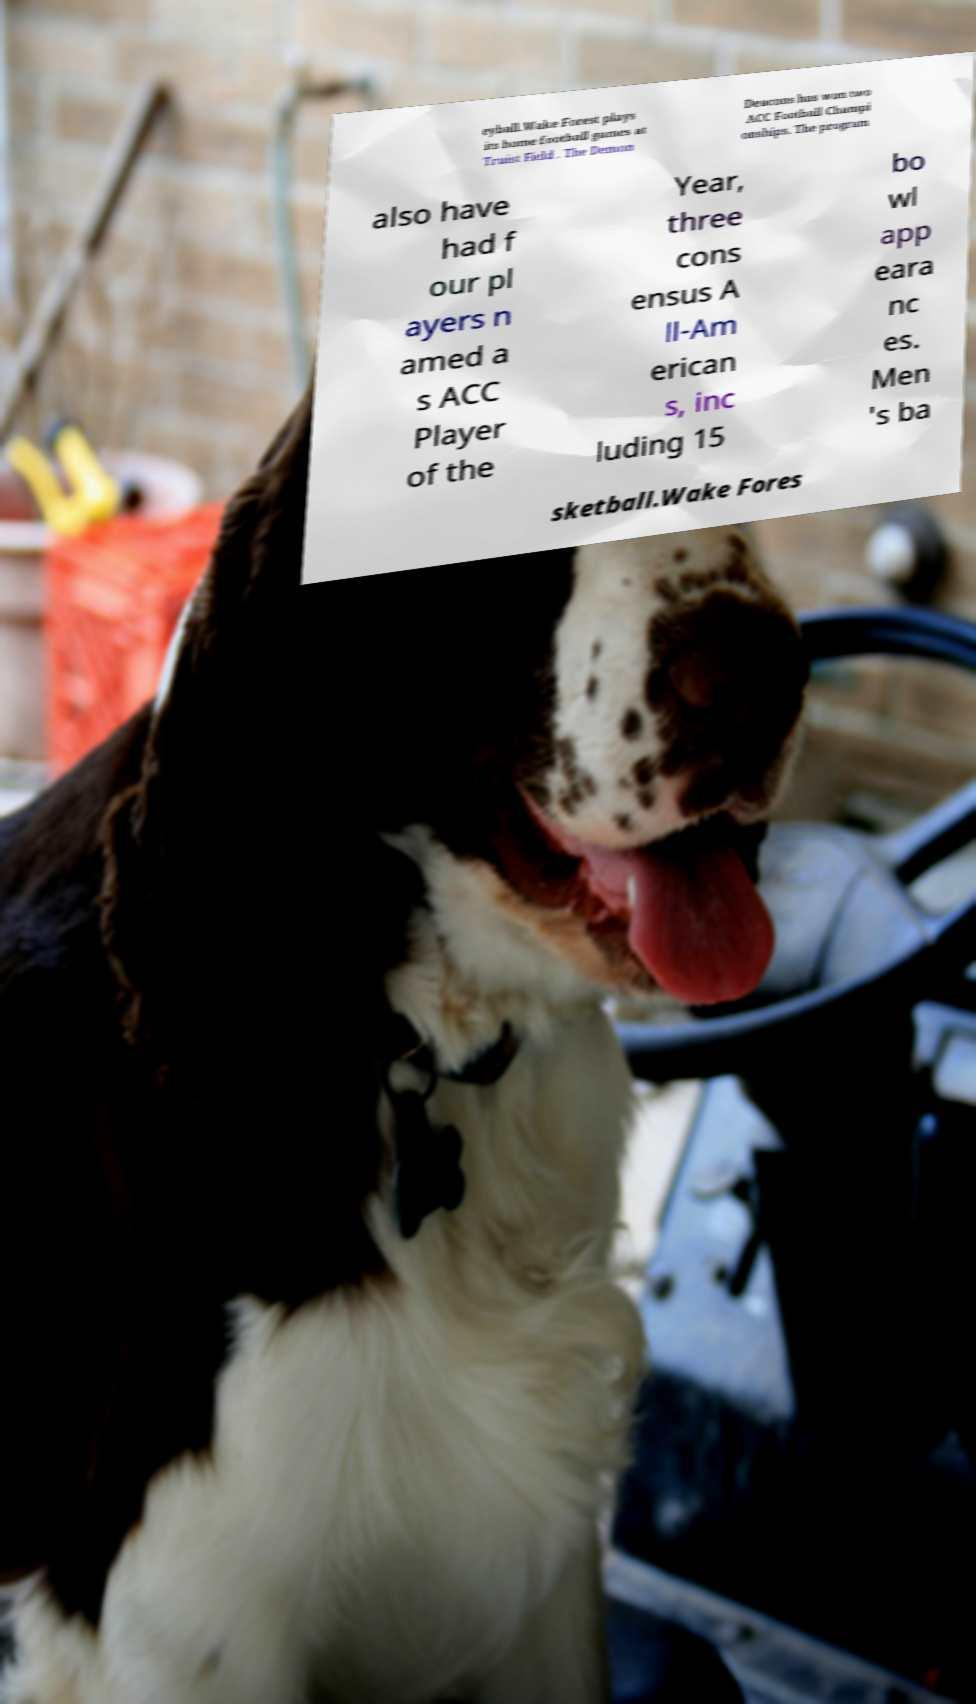Could you extract and type out the text from this image? eyball.Wake Forest plays its home football games at Truist Field . The Demon Deacons has won two ACC Football Champi onships. The program also have had f our pl ayers n amed a s ACC Player of the Year, three cons ensus A ll-Am erican s, inc luding 15 bo wl app eara nc es. Men 's ba sketball.Wake Fores 